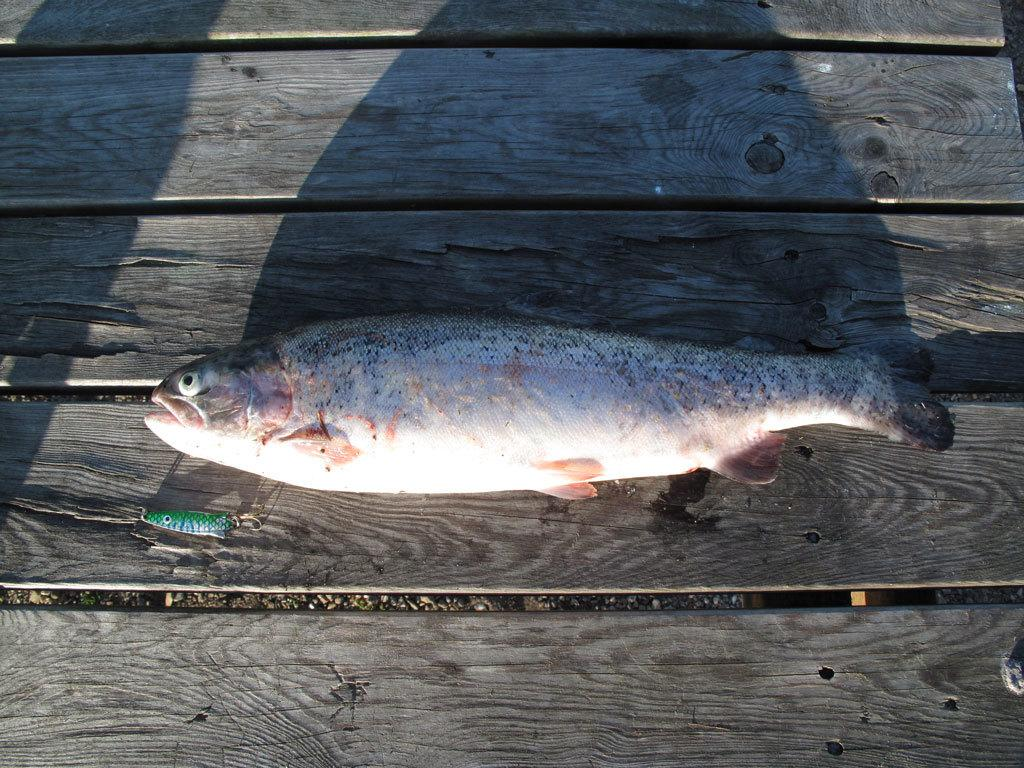What type of animal is in the image? There is a fish in the image. What is the fish resting on? The fish is on a wooden surface. Can you describe the color of the fish? The fish has a white and cream color. What role does the actor play in the image? There is no actor present in the image; it features a fish on a wooden surface. 